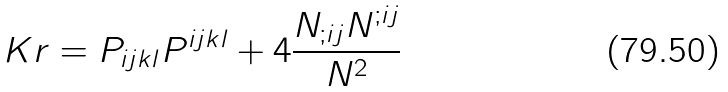<formula> <loc_0><loc_0><loc_500><loc_500>K r = P _ { i j k l } P ^ { i j k l } + 4 \frac { N _ { ; i j } N ^ { ; i j } } { N ^ { 2 } }</formula> 